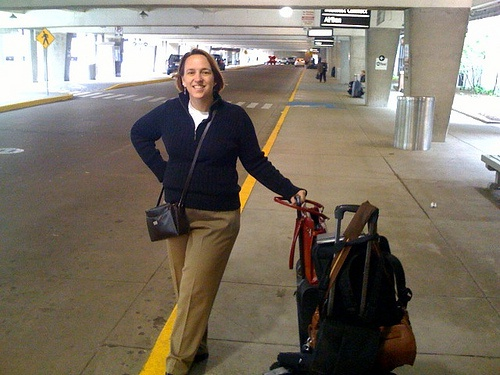Describe the objects in this image and their specific colors. I can see people in darkgray, black, olive, maroon, and gray tones, suitcase in darkgray, black, maroon, and gray tones, handbag in darkgray, black, and gray tones, handbag in darkgray, maroon, black, gray, and brown tones, and bench in darkgray, gray, white, and black tones in this image. 